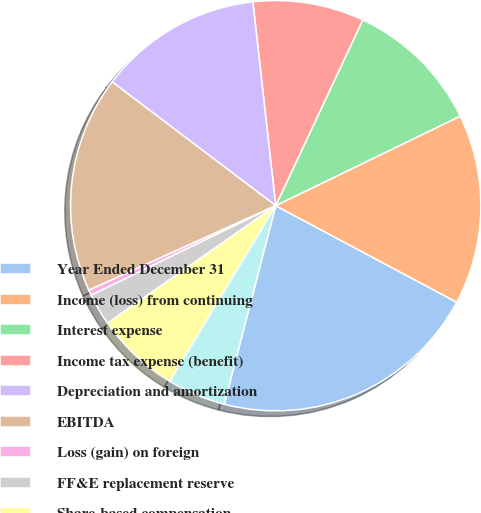Convert chart to OTSL. <chart><loc_0><loc_0><loc_500><loc_500><pie_chart><fcel>Year Ended December 31<fcel>Income (loss) from continuing<fcel>Interest expense<fcel>Income tax expense (benefit)<fcel>Depreciation and amortization<fcel>EBITDA<fcel>Loss (gain) on foreign<fcel>FF&E replacement reserve<fcel>Share-based compensation<fcel>Other adjustment items (1)<nl><fcel>21.23%<fcel>14.99%<fcel>10.83%<fcel>8.75%<fcel>12.91%<fcel>17.07%<fcel>0.43%<fcel>2.51%<fcel>6.67%<fcel>4.59%<nl></chart> 